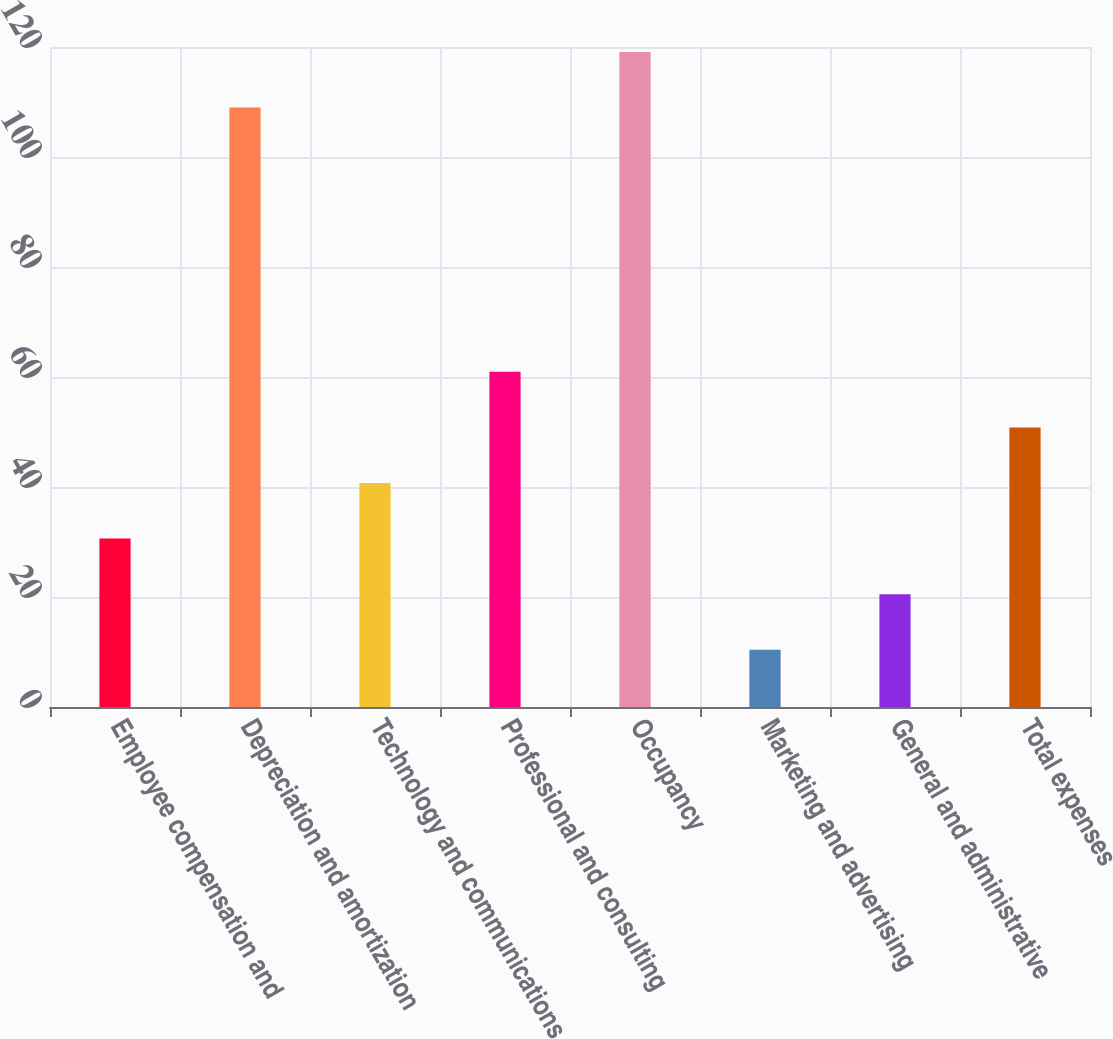Convert chart. <chart><loc_0><loc_0><loc_500><loc_500><bar_chart><fcel>Employee compensation and<fcel>Depreciation and amortization<fcel>Technology and communications<fcel>Professional and consulting<fcel>Occupancy<fcel>Marketing and advertising<fcel>General and administrative<fcel>Total expenses<nl><fcel>30.62<fcel>109<fcel>40.73<fcel>60.95<fcel>119.11<fcel>10.4<fcel>20.51<fcel>50.84<nl></chart> 